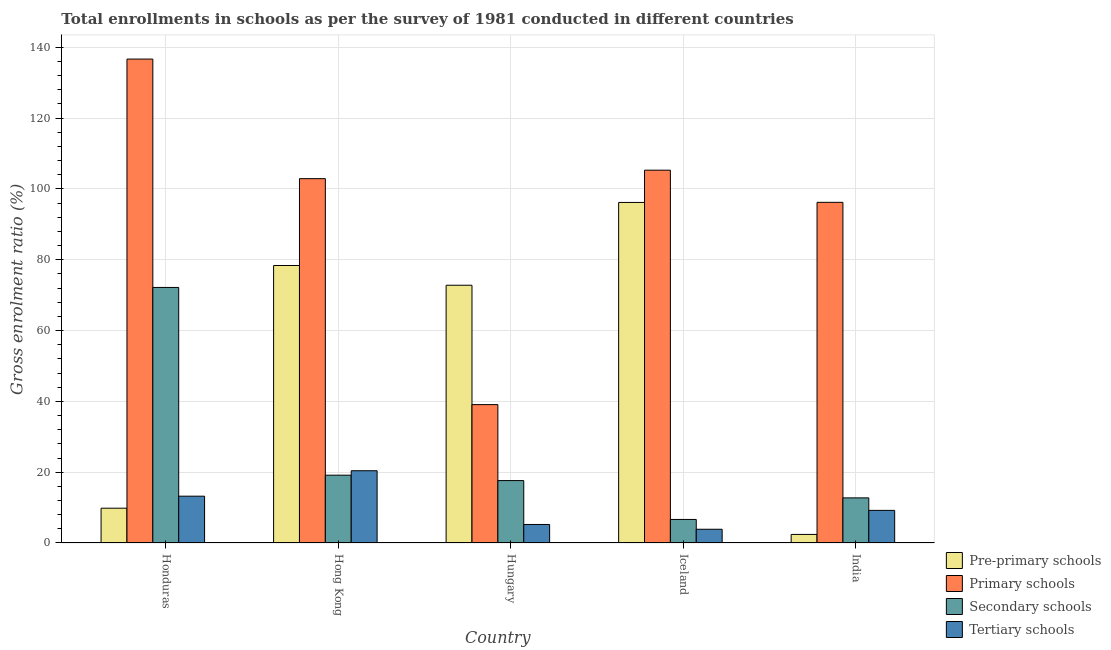How many different coloured bars are there?
Make the answer very short. 4. How many groups of bars are there?
Make the answer very short. 5. Are the number of bars per tick equal to the number of legend labels?
Offer a terse response. Yes. How many bars are there on the 4th tick from the left?
Your response must be concise. 4. What is the label of the 1st group of bars from the left?
Offer a very short reply. Honduras. In how many cases, is the number of bars for a given country not equal to the number of legend labels?
Your response must be concise. 0. What is the gross enrolment ratio in pre-primary schools in Hungary?
Make the answer very short. 72.79. Across all countries, what is the maximum gross enrolment ratio in primary schools?
Provide a short and direct response. 136.66. Across all countries, what is the minimum gross enrolment ratio in pre-primary schools?
Your answer should be compact. 2.42. In which country was the gross enrolment ratio in tertiary schools maximum?
Provide a succinct answer. Hong Kong. In which country was the gross enrolment ratio in primary schools minimum?
Give a very brief answer. Hungary. What is the total gross enrolment ratio in pre-primary schools in the graph?
Provide a succinct answer. 259.56. What is the difference between the gross enrolment ratio in tertiary schools in Honduras and that in Hong Kong?
Your response must be concise. -7.18. What is the difference between the gross enrolment ratio in secondary schools in Hungary and the gross enrolment ratio in pre-primary schools in Honduras?
Give a very brief answer. 7.8. What is the average gross enrolment ratio in secondary schools per country?
Ensure brevity in your answer.  25.67. What is the difference between the gross enrolment ratio in secondary schools and gross enrolment ratio in primary schools in Hong Kong?
Your response must be concise. -83.74. What is the ratio of the gross enrolment ratio in pre-primary schools in Honduras to that in Hungary?
Offer a terse response. 0.13. Is the difference between the gross enrolment ratio in tertiary schools in Hungary and Iceland greater than the difference between the gross enrolment ratio in secondary schools in Hungary and Iceland?
Your answer should be very brief. No. What is the difference between the highest and the second highest gross enrolment ratio in primary schools?
Offer a very short reply. 31.38. What is the difference between the highest and the lowest gross enrolment ratio in tertiary schools?
Offer a terse response. 16.52. In how many countries, is the gross enrolment ratio in pre-primary schools greater than the average gross enrolment ratio in pre-primary schools taken over all countries?
Provide a short and direct response. 3. Is the sum of the gross enrolment ratio in primary schools in Iceland and India greater than the maximum gross enrolment ratio in pre-primary schools across all countries?
Offer a very short reply. Yes. What does the 1st bar from the left in India represents?
Your answer should be compact. Pre-primary schools. What does the 2nd bar from the right in Honduras represents?
Your answer should be very brief. Secondary schools. Are all the bars in the graph horizontal?
Provide a succinct answer. No. How many countries are there in the graph?
Your response must be concise. 5. What is the difference between two consecutive major ticks on the Y-axis?
Your response must be concise. 20. Are the values on the major ticks of Y-axis written in scientific E-notation?
Provide a short and direct response. No. Does the graph contain any zero values?
Ensure brevity in your answer.  No. Does the graph contain grids?
Ensure brevity in your answer.  Yes. How many legend labels are there?
Provide a succinct answer. 4. How are the legend labels stacked?
Provide a succinct answer. Vertical. What is the title of the graph?
Provide a succinct answer. Total enrollments in schools as per the survey of 1981 conducted in different countries. Does "Agricultural land" appear as one of the legend labels in the graph?
Provide a short and direct response. No. What is the label or title of the Y-axis?
Your answer should be very brief. Gross enrolment ratio (%). What is the Gross enrolment ratio (%) in Pre-primary schools in Honduras?
Keep it short and to the point. 9.82. What is the Gross enrolment ratio (%) in Primary schools in Honduras?
Offer a terse response. 136.66. What is the Gross enrolment ratio (%) in Secondary schools in Honduras?
Ensure brevity in your answer.  72.17. What is the Gross enrolment ratio (%) in Tertiary schools in Honduras?
Keep it short and to the point. 13.22. What is the Gross enrolment ratio (%) in Pre-primary schools in Hong Kong?
Keep it short and to the point. 78.36. What is the Gross enrolment ratio (%) of Primary schools in Hong Kong?
Ensure brevity in your answer.  102.89. What is the Gross enrolment ratio (%) in Secondary schools in Hong Kong?
Offer a terse response. 19.15. What is the Gross enrolment ratio (%) in Tertiary schools in Hong Kong?
Your answer should be very brief. 20.4. What is the Gross enrolment ratio (%) in Pre-primary schools in Hungary?
Your answer should be very brief. 72.79. What is the Gross enrolment ratio (%) in Primary schools in Hungary?
Your answer should be compact. 39.07. What is the Gross enrolment ratio (%) of Secondary schools in Hungary?
Offer a terse response. 17.62. What is the Gross enrolment ratio (%) in Tertiary schools in Hungary?
Provide a succinct answer. 5.23. What is the Gross enrolment ratio (%) in Pre-primary schools in Iceland?
Keep it short and to the point. 96.17. What is the Gross enrolment ratio (%) in Primary schools in Iceland?
Provide a succinct answer. 105.28. What is the Gross enrolment ratio (%) in Secondary schools in Iceland?
Ensure brevity in your answer.  6.65. What is the Gross enrolment ratio (%) of Tertiary schools in Iceland?
Provide a succinct answer. 3.88. What is the Gross enrolment ratio (%) in Pre-primary schools in India?
Your response must be concise. 2.42. What is the Gross enrolment ratio (%) of Primary schools in India?
Provide a succinct answer. 96.2. What is the Gross enrolment ratio (%) of Secondary schools in India?
Give a very brief answer. 12.74. What is the Gross enrolment ratio (%) in Tertiary schools in India?
Your answer should be compact. 9.21. Across all countries, what is the maximum Gross enrolment ratio (%) in Pre-primary schools?
Ensure brevity in your answer.  96.17. Across all countries, what is the maximum Gross enrolment ratio (%) in Primary schools?
Your answer should be compact. 136.66. Across all countries, what is the maximum Gross enrolment ratio (%) of Secondary schools?
Your response must be concise. 72.17. Across all countries, what is the maximum Gross enrolment ratio (%) in Tertiary schools?
Provide a short and direct response. 20.4. Across all countries, what is the minimum Gross enrolment ratio (%) in Pre-primary schools?
Give a very brief answer. 2.42. Across all countries, what is the minimum Gross enrolment ratio (%) in Primary schools?
Ensure brevity in your answer.  39.07. Across all countries, what is the minimum Gross enrolment ratio (%) in Secondary schools?
Your response must be concise. 6.65. Across all countries, what is the minimum Gross enrolment ratio (%) of Tertiary schools?
Your answer should be very brief. 3.88. What is the total Gross enrolment ratio (%) in Pre-primary schools in the graph?
Provide a succinct answer. 259.56. What is the total Gross enrolment ratio (%) of Primary schools in the graph?
Provide a succinct answer. 480.1. What is the total Gross enrolment ratio (%) of Secondary schools in the graph?
Provide a succinct answer. 128.33. What is the total Gross enrolment ratio (%) of Tertiary schools in the graph?
Your answer should be compact. 51.94. What is the difference between the Gross enrolment ratio (%) in Pre-primary schools in Honduras and that in Hong Kong?
Offer a very short reply. -68.54. What is the difference between the Gross enrolment ratio (%) of Primary schools in Honduras and that in Hong Kong?
Ensure brevity in your answer.  33.77. What is the difference between the Gross enrolment ratio (%) of Secondary schools in Honduras and that in Hong Kong?
Ensure brevity in your answer.  53.02. What is the difference between the Gross enrolment ratio (%) in Tertiary schools in Honduras and that in Hong Kong?
Your answer should be very brief. -7.18. What is the difference between the Gross enrolment ratio (%) in Pre-primary schools in Honduras and that in Hungary?
Keep it short and to the point. -62.96. What is the difference between the Gross enrolment ratio (%) of Primary schools in Honduras and that in Hungary?
Ensure brevity in your answer.  97.58. What is the difference between the Gross enrolment ratio (%) of Secondary schools in Honduras and that in Hungary?
Offer a very short reply. 54.54. What is the difference between the Gross enrolment ratio (%) of Tertiary schools in Honduras and that in Hungary?
Offer a terse response. 7.99. What is the difference between the Gross enrolment ratio (%) of Pre-primary schools in Honduras and that in Iceland?
Make the answer very short. -86.34. What is the difference between the Gross enrolment ratio (%) of Primary schools in Honduras and that in Iceland?
Ensure brevity in your answer.  31.38. What is the difference between the Gross enrolment ratio (%) in Secondary schools in Honduras and that in Iceland?
Provide a short and direct response. 65.52. What is the difference between the Gross enrolment ratio (%) of Tertiary schools in Honduras and that in Iceland?
Provide a short and direct response. 9.34. What is the difference between the Gross enrolment ratio (%) in Pre-primary schools in Honduras and that in India?
Ensure brevity in your answer.  7.41. What is the difference between the Gross enrolment ratio (%) in Primary schools in Honduras and that in India?
Keep it short and to the point. 40.46. What is the difference between the Gross enrolment ratio (%) of Secondary schools in Honduras and that in India?
Your answer should be compact. 59.43. What is the difference between the Gross enrolment ratio (%) in Tertiary schools in Honduras and that in India?
Provide a succinct answer. 4.01. What is the difference between the Gross enrolment ratio (%) of Pre-primary schools in Hong Kong and that in Hungary?
Offer a very short reply. 5.57. What is the difference between the Gross enrolment ratio (%) of Primary schools in Hong Kong and that in Hungary?
Offer a very short reply. 63.81. What is the difference between the Gross enrolment ratio (%) of Secondary schools in Hong Kong and that in Hungary?
Offer a very short reply. 1.53. What is the difference between the Gross enrolment ratio (%) of Tertiary schools in Hong Kong and that in Hungary?
Keep it short and to the point. 15.17. What is the difference between the Gross enrolment ratio (%) of Pre-primary schools in Hong Kong and that in Iceland?
Ensure brevity in your answer.  -17.81. What is the difference between the Gross enrolment ratio (%) in Primary schools in Hong Kong and that in Iceland?
Provide a succinct answer. -2.39. What is the difference between the Gross enrolment ratio (%) in Secondary schools in Hong Kong and that in Iceland?
Offer a very short reply. 12.5. What is the difference between the Gross enrolment ratio (%) in Tertiary schools in Hong Kong and that in Iceland?
Ensure brevity in your answer.  16.52. What is the difference between the Gross enrolment ratio (%) of Pre-primary schools in Hong Kong and that in India?
Provide a short and direct response. 75.94. What is the difference between the Gross enrolment ratio (%) in Primary schools in Hong Kong and that in India?
Provide a short and direct response. 6.69. What is the difference between the Gross enrolment ratio (%) in Secondary schools in Hong Kong and that in India?
Keep it short and to the point. 6.41. What is the difference between the Gross enrolment ratio (%) in Tertiary schools in Hong Kong and that in India?
Your answer should be compact. 11.19. What is the difference between the Gross enrolment ratio (%) of Pre-primary schools in Hungary and that in Iceland?
Offer a terse response. -23.38. What is the difference between the Gross enrolment ratio (%) of Primary schools in Hungary and that in Iceland?
Your response must be concise. -66.21. What is the difference between the Gross enrolment ratio (%) of Secondary schools in Hungary and that in Iceland?
Provide a short and direct response. 10.97. What is the difference between the Gross enrolment ratio (%) in Tertiary schools in Hungary and that in Iceland?
Offer a very short reply. 1.35. What is the difference between the Gross enrolment ratio (%) of Pre-primary schools in Hungary and that in India?
Your answer should be very brief. 70.37. What is the difference between the Gross enrolment ratio (%) of Primary schools in Hungary and that in India?
Your answer should be compact. -57.13. What is the difference between the Gross enrolment ratio (%) of Secondary schools in Hungary and that in India?
Your answer should be very brief. 4.88. What is the difference between the Gross enrolment ratio (%) of Tertiary schools in Hungary and that in India?
Your response must be concise. -3.98. What is the difference between the Gross enrolment ratio (%) in Pre-primary schools in Iceland and that in India?
Your answer should be compact. 93.75. What is the difference between the Gross enrolment ratio (%) of Primary schools in Iceland and that in India?
Your answer should be very brief. 9.08. What is the difference between the Gross enrolment ratio (%) in Secondary schools in Iceland and that in India?
Your answer should be compact. -6.09. What is the difference between the Gross enrolment ratio (%) in Tertiary schools in Iceland and that in India?
Your response must be concise. -5.33. What is the difference between the Gross enrolment ratio (%) of Pre-primary schools in Honduras and the Gross enrolment ratio (%) of Primary schools in Hong Kong?
Ensure brevity in your answer.  -93.06. What is the difference between the Gross enrolment ratio (%) of Pre-primary schools in Honduras and the Gross enrolment ratio (%) of Secondary schools in Hong Kong?
Make the answer very short. -9.32. What is the difference between the Gross enrolment ratio (%) of Pre-primary schools in Honduras and the Gross enrolment ratio (%) of Tertiary schools in Hong Kong?
Give a very brief answer. -10.58. What is the difference between the Gross enrolment ratio (%) in Primary schools in Honduras and the Gross enrolment ratio (%) in Secondary schools in Hong Kong?
Your response must be concise. 117.51. What is the difference between the Gross enrolment ratio (%) of Primary schools in Honduras and the Gross enrolment ratio (%) of Tertiary schools in Hong Kong?
Your answer should be compact. 116.26. What is the difference between the Gross enrolment ratio (%) of Secondary schools in Honduras and the Gross enrolment ratio (%) of Tertiary schools in Hong Kong?
Offer a very short reply. 51.76. What is the difference between the Gross enrolment ratio (%) of Pre-primary schools in Honduras and the Gross enrolment ratio (%) of Primary schools in Hungary?
Ensure brevity in your answer.  -29.25. What is the difference between the Gross enrolment ratio (%) of Pre-primary schools in Honduras and the Gross enrolment ratio (%) of Secondary schools in Hungary?
Give a very brief answer. -7.8. What is the difference between the Gross enrolment ratio (%) of Pre-primary schools in Honduras and the Gross enrolment ratio (%) of Tertiary schools in Hungary?
Give a very brief answer. 4.6. What is the difference between the Gross enrolment ratio (%) in Primary schools in Honduras and the Gross enrolment ratio (%) in Secondary schools in Hungary?
Make the answer very short. 119.04. What is the difference between the Gross enrolment ratio (%) in Primary schools in Honduras and the Gross enrolment ratio (%) in Tertiary schools in Hungary?
Make the answer very short. 131.43. What is the difference between the Gross enrolment ratio (%) of Secondary schools in Honduras and the Gross enrolment ratio (%) of Tertiary schools in Hungary?
Your answer should be compact. 66.94. What is the difference between the Gross enrolment ratio (%) in Pre-primary schools in Honduras and the Gross enrolment ratio (%) in Primary schools in Iceland?
Your response must be concise. -95.46. What is the difference between the Gross enrolment ratio (%) in Pre-primary schools in Honduras and the Gross enrolment ratio (%) in Secondary schools in Iceland?
Give a very brief answer. 3.17. What is the difference between the Gross enrolment ratio (%) of Pre-primary schools in Honduras and the Gross enrolment ratio (%) of Tertiary schools in Iceland?
Provide a succinct answer. 5.94. What is the difference between the Gross enrolment ratio (%) of Primary schools in Honduras and the Gross enrolment ratio (%) of Secondary schools in Iceland?
Your answer should be very brief. 130.01. What is the difference between the Gross enrolment ratio (%) in Primary schools in Honduras and the Gross enrolment ratio (%) in Tertiary schools in Iceland?
Make the answer very short. 132.78. What is the difference between the Gross enrolment ratio (%) of Secondary schools in Honduras and the Gross enrolment ratio (%) of Tertiary schools in Iceland?
Ensure brevity in your answer.  68.29. What is the difference between the Gross enrolment ratio (%) of Pre-primary schools in Honduras and the Gross enrolment ratio (%) of Primary schools in India?
Your answer should be compact. -86.38. What is the difference between the Gross enrolment ratio (%) of Pre-primary schools in Honduras and the Gross enrolment ratio (%) of Secondary schools in India?
Give a very brief answer. -2.92. What is the difference between the Gross enrolment ratio (%) of Pre-primary schools in Honduras and the Gross enrolment ratio (%) of Tertiary schools in India?
Make the answer very short. 0.62. What is the difference between the Gross enrolment ratio (%) in Primary schools in Honduras and the Gross enrolment ratio (%) in Secondary schools in India?
Offer a terse response. 123.92. What is the difference between the Gross enrolment ratio (%) of Primary schools in Honduras and the Gross enrolment ratio (%) of Tertiary schools in India?
Provide a succinct answer. 127.45. What is the difference between the Gross enrolment ratio (%) in Secondary schools in Honduras and the Gross enrolment ratio (%) in Tertiary schools in India?
Offer a terse response. 62.96. What is the difference between the Gross enrolment ratio (%) in Pre-primary schools in Hong Kong and the Gross enrolment ratio (%) in Primary schools in Hungary?
Keep it short and to the point. 39.29. What is the difference between the Gross enrolment ratio (%) of Pre-primary schools in Hong Kong and the Gross enrolment ratio (%) of Secondary schools in Hungary?
Offer a terse response. 60.74. What is the difference between the Gross enrolment ratio (%) of Pre-primary schools in Hong Kong and the Gross enrolment ratio (%) of Tertiary schools in Hungary?
Your answer should be compact. 73.13. What is the difference between the Gross enrolment ratio (%) in Primary schools in Hong Kong and the Gross enrolment ratio (%) in Secondary schools in Hungary?
Offer a very short reply. 85.27. What is the difference between the Gross enrolment ratio (%) in Primary schools in Hong Kong and the Gross enrolment ratio (%) in Tertiary schools in Hungary?
Make the answer very short. 97.66. What is the difference between the Gross enrolment ratio (%) of Secondary schools in Hong Kong and the Gross enrolment ratio (%) of Tertiary schools in Hungary?
Give a very brief answer. 13.92. What is the difference between the Gross enrolment ratio (%) of Pre-primary schools in Hong Kong and the Gross enrolment ratio (%) of Primary schools in Iceland?
Your answer should be compact. -26.92. What is the difference between the Gross enrolment ratio (%) of Pre-primary schools in Hong Kong and the Gross enrolment ratio (%) of Secondary schools in Iceland?
Make the answer very short. 71.71. What is the difference between the Gross enrolment ratio (%) in Pre-primary schools in Hong Kong and the Gross enrolment ratio (%) in Tertiary schools in Iceland?
Ensure brevity in your answer.  74.48. What is the difference between the Gross enrolment ratio (%) of Primary schools in Hong Kong and the Gross enrolment ratio (%) of Secondary schools in Iceland?
Provide a short and direct response. 96.24. What is the difference between the Gross enrolment ratio (%) in Primary schools in Hong Kong and the Gross enrolment ratio (%) in Tertiary schools in Iceland?
Your answer should be very brief. 99.01. What is the difference between the Gross enrolment ratio (%) in Secondary schools in Hong Kong and the Gross enrolment ratio (%) in Tertiary schools in Iceland?
Provide a short and direct response. 15.27. What is the difference between the Gross enrolment ratio (%) of Pre-primary schools in Hong Kong and the Gross enrolment ratio (%) of Primary schools in India?
Provide a succinct answer. -17.84. What is the difference between the Gross enrolment ratio (%) of Pre-primary schools in Hong Kong and the Gross enrolment ratio (%) of Secondary schools in India?
Offer a very short reply. 65.62. What is the difference between the Gross enrolment ratio (%) in Pre-primary schools in Hong Kong and the Gross enrolment ratio (%) in Tertiary schools in India?
Ensure brevity in your answer.  69.15. What is the difference between the Gross enrolment ratio (%) in Primary schools in Hong Kong and the Gross enrolment ratio (%) in Secondary schools in India?
Your answer should be very brief. 90.15. What is the difference between the Gross enrolment ratio (%) in Primary schools in Hong Kong and the Gross enrolment ratio (%) in Tertiary schools in India?
Your answer should be compact. 93.68. What is the difference between the Gross enrolment ratio (%) in Secondary schools in Hong Kong and the Gross enrolment ratio (%) in Tertiary schools in India?
Your answer should be very brief. 9.94. What is the difference between the Gross enrolment ratio (%) in Pre-primary schools in Hungary and the Gross enrolment ratio (%) in Primary schools in Iceland?
Provide a succinct answer. -32.49. What is the difference between the Gross enrolment ratio (%) in Pre-primary schools in Hungary and the Gross enrolment ratio (%) in Secondary schools in Iceland?
Your answer should be very brief. 66.14. What is the difference between the Gross enrolment ratio (%) of Pre-primary schools in Hungary and the Gross enrolment ratio (%) of Tertiary schools in Iceland?
Offer a very short reply. 68.91. What is the difference between the Gross enrolment ratio (%) of Primary schools in Hungary and the Gross enrolment ratio (%) of Secondary schools in Iceland?
Your answer should be compact. 32.42. What is the difference between the Gross enrolment ratio (%) of Primary schools in Hungary and the Gross enrolment ratio (%) of Tertiary schools in Iceland?
Make the answer very short. 35.19. What is the difference between the Gross enrolment ratio (%) in Secondary schools in Hungary and the Gross enrolment ratio (%) in Tertiary schools in Iceland?
Your answer should be very brief. 13.74. What is the difference between the Gross enrolment ratio (%) in Pre-primary schools in Hungary and the Gross enrolment ratio (%) in Primary schools in India?
Provide a short and direct response. -23.41. What is the difference between the Gross enrolment ratio (%) of Pre-primary schools in Hungary and the Gross enrolment ratio (%) of Secondary schools in India?
Offer a terse response. 60.05. What is the difference between the Gross enrolment ratio (%) of Pre-primary schools in Hungary and the Gross enrolment ratio (%) of Tertiary schools in India?
Your answer should be compact. 63.58. What is the difference between the Gross enrolment ratio (%) of Primary schools in Hungary and the Gross enrolment ratio (%) of Secondary schools in India?
Ensure brevity in your answer.  26.33. What is the difference between the Gross enrolment ratio (%) in Primary schools in Hungary and the Gross enrolment ratio (%) in Tertiary schools in India?
Provide a succinct answer. 29.87. What is the difference between the Gross enrolment ratio (%) in Secondary schools in Hungary and the Gross enrolment ratio (%) in Tertiary schools in India?
Make the answer very short. 8.41. What is the difference between the Gross enrolment ratio (%) of Pre-primary schools in Iceland and the Gross enrolment ratio (%) of Primary schools in India?
Your answer should be very brief. -0.03. What is the difference between the Gross enrolment ratio (%) in Pre-primary schools in Iceland and the Gross enrolment ratio (%) in Secondary schools in India?
Give a very brief answer. 83.43. What is the difference between the Gross enrolment ratio (%) in Pre-primary schools in Iceland and the Gross enrolment ratio (%) in Tertiary schools in India?
Make the answer very short. 86.96. What is the difference between the Gross enrolment ratio (%) in Primary schools in Iceland and the Gross enrolment ratio (%) in Secondary schools in India?
Give a very brief answer. 92.54. What is the difference between the Gross enrolment ratio (%) in Primary schools in Iceland and the Gross enrolment ratio (%) in Tertiary schools in India?
Give a very brief answer. 96.07. What is the difference between the Gross enrolment ratio (%) in Secondary schools in Iceland and the Gross enrolment ratio (%) in Tertiary schools in India?
Provide a short and direct response. -2.56. What is the average Gross enrolment ratio (%) of Pre-primary schools per country?
Make the answer very short. 51.91. What is the average Gross enrolment ratio (%) in Primary schools per country?
Give a very brief answer. 96.02. What is the average Gross enrolment ratio (%) of Secondary schools per country?
Provide a short and direct response. 25.67. What is the average Gross enrolment ratio (%) in Tertiary schools per country?
Your answer should be very brief. 10.39. What is the difference between the Gross enrolment ratio (%) in Pre-primary schools and Gross enrolment ratio (%) in Primary schools in Honduras?
Give a very brief answer. -126.84. What is the difference between the Gross enrolment ratio (%) of Pre-primary schools and Gross enrolment ratio (%) of Secondary schools in Honduras?
Keep it short and to the point. -62.34. What is the difference between the Gross enrolment ratio (%) in Pre-primary schools and Gross enrolment ratio (%) in Tertiary schools in Honduras?
Your response must be concise. -3.4. What is the difference between the Gross enrolment ratio (%) of Primary schools and Gross enrolment ratio (%) of Secondary schools in Honduras?
Offer a very short reply. 64.49. What is the difference between the Gross enrolment ratio (%) in Primary schools and Gross enrolment ratio (%) in Tertiary schools in Honduras?
Provide a succinct answer. 123.44. What is the difference between the Gross enrolment ratio (%) of Secondary schools and Gross enrolment ratio (%) of Tertiary schools in Honduras?
Ensure brevity in your answer.  58.95. What is the difference between the Gross enrolment ratio (%) in Pre-primary schools and Gross enrolment ratio (%) in Primary schools in Hong Kong?
Ensure brevity in your answer.  -24.53. What is the difference between the Gross enrolment ratio (%) of Pre-primary schools and Gross enrolment ratio (%) of Secondary schools in Hong Kong?
Provide a short and direct response. 59.21. What is the difference between the Gross enrolment ratio (%) of Pre-primary schools and Gross enrolment ratio (%) of Tertiary schools in Hong Kong?
Provide a succinct answer. 57.96. What is the difference between the Gross enrolment ratio (%) of Primary schools and Gross enrolment ratio (%) of Secondary schools in Hong Kong?
Offer a very short reply. 83.74. What is the difference between the Gross enrolment ratio (%) of Primary schools and Gross enrolment ratio (%) of Tertiary schools in Hong Kong?
Your answer should be very brief. 82.49. What is the difference between the Gross enrolment ratio (%) of Secondary schools and Gross enrolment ratio (%) of Tertiary schools in Hong Kong?
Your response must be concise. -1.25. What is the difference between the Gross enrolment ratio (%) in Pre-primary schools and Gross enrolment ratio (%) in Primary schools in Hungary?
Provide a short and direct response. 33.71. What is the difference between the Gross enrolment ratio (%) in Pre-primary schools and Gross enrolment ratio (%) in Secondary schools in Hungary?
Your response must be concise. 55.17. What is the difference between the Gross enrolment ratio (%) of Pre-primary schools and Gross enrolment ratio (%) of Tertiary schools in Hungary?
Offer a very short reply. 67.56. What is the difference between the Gross enrolment ratio (%) in Primary schools and Gross enrolment ratio (%) in Secondary schools in Hungary?
Make the answer very short. 21.45. What is the difference between the Gross enrolment ratio (%) in Primary schools and Gross enrolment ratio (%) in Tertiary schools in Hungary?
Ensure brevity in your answer.  33.85. What is the difference between the Gross enrolment ratio (%) in Secondary schools and Gross enrolment ratio (%) in Tertiary schools in Hungary?
Your response must be concise. 12.39. What is the difference between the Gross enrolment ratio (%) of Pre-primary schools and Gross enrolment ratio (%) of Primary schools in Iceland?
Your answer should be compact. -9.11. What is the difference between the Gross enrolment ratio (%) in Pre-primary schools and Gross enrolment ratio (%) in Secondary schools in Iceland?
Offer a terse response. 89.52. What is the difference between the Gross enrolment ratio (%) of Pre-primary schools and Gross enrolment ratio (%) of Tertiary schools in Iceland?
Your answer should be compact. 92.29. What is the difference between the Gross enrolment ratio (%) of Primary schools and Gross enrolment ratio (%) of Secondary schools in Iceland?
Your response must be concise. 98.63. What is the difference between the Gross enrolment ratio (%) of Primary schools and Gross enrolment ratio (%) of Tertiary schools in Iceland?
Provide a short and direct response. 101.4. What is the difference between the Gross enrolment ratio (%) of Secondary schools and Gross enrolment ratio (%) of Tertiary schools in Iceland?
Give a very brief answer. 2.77. What is the difference between the Gross enrolment ratio (%) of Pre-primary schools and Gross enrolment ratio (%) of Primary schools in India?
Your answer should be compact. -93.78. What is the difference between the Gross enrolment ratio (%) of Pre-primary schools and Gross enrolment ratio (%) of Secondary schools in India?
Make the answer very short. -10.32. What is the difference between the Gross enrolment ratio (%) of Pre-primary schools and Gross enrolment ratio (%) of Tertiary schools in India?
Your response must be concise. -6.79. What is the difference between the Gross enrolment ratio (%) of Primary schools and Gross enrolment ratio (%) of Secondary schools in India?
Your response must be concise. 83.46. What is the difference between the Gross enrolment ratio (%) in Primary schools and Gross enrolment ratio (%) in Tertiary schools in India?
Make the answer very short. 86.99. What is the difference between the Gross enrolment ratio (%) in Secondary schools and Gross enrolment ratio (%) in Tertiary schools in India?
Offer a terse response. 3.53. What is the ratio of the Gross enrolment ratio (%) of Pre-primary schools in Honduras to that in Hong Kong?
Offer a terse response. 0.13. What is the ratio of the Gross enrolment ratio (%) of Primary schools in Honduras to that in Hong Kong?
Offer a terse response. 1.33. What is the ratio of the Gross enrolment ratio (%) in Secondary schools in Honduras to that in Hong Kong?
Make the answer very short. 3.77. What is the ratio of the Gross enrolment ratio (%) in Tertiary schools in Honduras to that in Hong Kong?
Provide a succinct answer. 0.65. What is the ratio of the Gross enrolment ratio (%) in Pre-primary schools in Honduras to that in Hungary?
Your response must be concise. 0.14. What is the ratio of the Gross enrolment ratio (%) in Primary schools in Honduras to that in Hungary?
Provide a succinct answer. 3.5. What is the ratio of the Gross enrolment ratio (%) in Secondary schools in Honduras to that in Hungary?
Your answer should be compact. 4.1. What is the ratio of the Gross enrolment ratio (%) in Tertiary schools in Honduras to that in Hungary?
Provide a succinct answer. 2.53. What is the ratio of the Gross enrolment ratio (%) of Pre-primary schools in Honduras to that in Iceland?
Offer a terse response. 0.1. What is the ratio of the Gross enrolment ratio (%) in Primary schools in Honduras to that in Iceland?
Offer a very short reply. 1.3. What is the ratio of the Gross enrolment ratio (%) in Secondary schools in Honduras to that in Iceland?
Your answer should be compact. 10.85. What is the ratio of the Gross enrolment ratio (%) in Tertiary schools in Honduras to that in Iceland?
Make the answer very short. 3.41. What is the ratio of the Gross enrolment ratio (%) in Pre-primary schools in Honduras to that in India?
Your answer should be very brief. 4.07. What is the ratio of the Gross enrolment ratio (%) in Primary schools in Honduras to that in India?
Your response must be concise. 1.42. What is the ratio of the Gross enrolment ratio (%) in Secondary schools in Honduras to that in India?
Keep it short and to the point. 5.66. What is the ratio of the Gross enrolment ratio (%) in Tertiary schools in Honduras to that in India?
Your response must be concise. 1.44. What is the ratio of the Gross enrolment ratio (%) in Pre-primary schools in Hong Kong to that in Hungary?
Your answer should be compact. 1.08. What is the ratio of the Gross enrolment ratio (%) of Primary schools in Hong Kong to that in Hungary?
Your response must be concise. 2.63. What is the ratio of the Gross enrolment ratio (%) of Secondary schools in Hong Kong to that in Hungary?
Your answer should be compact. 1.09. What is the ratio of the Gross enrolment ratio (%) of Tertiary schools in Hong Kong to that in Hungary?
Provide a short and direct response. 3.9. What is the ratio of the Gross enrolment ratio (%) of Pre-primary schools in Hong Kong to that in Iceland?
Offer a very short reply. 0.81. What is the ratio of the Gross enrolment ratio (%) of Primary schools in Hong Kong to that in Iceland?
Provide a short and direct response. 0.98. What is the ratio of the Gross enrolment ratio (%) of Secondary schools in Hong Kong to that in Iceland?
Keep it short and to the point. 2.88. What is the ratio of the Gross enrolment ratio (%) of Tertiary schools in Hong Kong to that in Iceland?
Your response must be concise. 5.26. What is the ratio of the Gross enrolment ratio (%) in Pre-primary schools in Hong Kong to that in India?
Make the answer very short. 32.42. What is the ratio of the Gross enrolment ratio (%) of Primary schools in Hong Kong to that in India?
Your answer should be very brief. 1.07. What is the ratio of the Gross enrolment ratio (%) of Secondary schools in Hong Kong to that in India?
Provide a succinct answer. 1.5. What is the ratio of the Gross enrolment ratio (%) of Tertiary schools in Hong Kong to that in India?
Make the answer very short. 2.22. What is the ratio of the Gross enrolment ratio (%) of Pre-primary schools in Hungary to that in Iceland?
Ensure brevity in your answer.  0.76. What is the ratio of the Gross enrolment ratio (%) in Primary schools in Hungary to that in Iceland?
Make the answer very short. 0.37. What is the ratio of the Gross enrolment ratio (%) of Secondary schools in Hungary to that in Iceland?
Your answer should be compact. 2.65. What is the ratio of the Gross enrolment ratio (%) of Tertiary schools in Hungary to that in Iceland?
Ensure brevity in your answer.  1.35. What is the ratio of the Gross enrolment ratio (%) of Pre-primary schools in Hungary to that in India?
Offer a very short reply. 30.12. What is the ratio of the Gross enrolment ratio (%) in Primary schools in Hungary to that in India?
Offer a terse response. 0.41. What is the ratio of the Gross enrolment ratio (%) of Secondary schools in Hungary to that in India?
Ensure brevity in your answer.  1.38. What is the ratio of the Gross enrolment ratio (%) of Tertiary schools in Hungary to that in India?
Keep it short and to the point. 0.57. What is the ratio of the Gross enrolment ratio (%) in Pre-primary schools in Iceland to that in India?
Offer a terse response. 39.79. What is the ratio of the Gross enrolment ratio (%) in Primary schools in Iceland to that in India?
Offer a terse response. 1.09. What is the ratio of the Gross enrolment ratio (%) of Secondary schools in Iceland to that in India?
Ensure brevity in your answer.  0.52. What is the ratio of the Gross enrolment ratio (%) of Tertiary schools in Iceland to that in India?
Keep it short and to the point. 0.42. What is the difference between the highest and the second highest Gross enrolment ratio (%) in Pre-primary schools?
Make the answer very short. 17.81. What is the difference between the highest and the second highest Gross enrolment ratio (%) of Primary schools?
Offer a very short reply. 31.38. What is the difference between the highest and the second highest Gross enrolment ratio (%) in Secondary schools?
Your response must be concise. 53.02. What is the difference between the highest and the second highest Gross enrolment ratio (%) of Tertiary schools?
Offer a terse response. 7.18. What is the difference between the highest and the lowest Gross enrolment ratio (%) of Pre-primary schools?
Your answer should be compact. 93.75. What is the difference between the highest and the lowest Gross enrolment ratio (%) of Primary schools?
Your answer should be very brief. 97.58. What is the difference between the highest and the lowest Gross enrolment ratio (%) of Secondary schools?
Keep it short and to the point. 65.52. What is the difference between the highest and the lowest Gross enrolment ratio (%) in Tertiary schools?
Offer a very short reply. 16.52. 